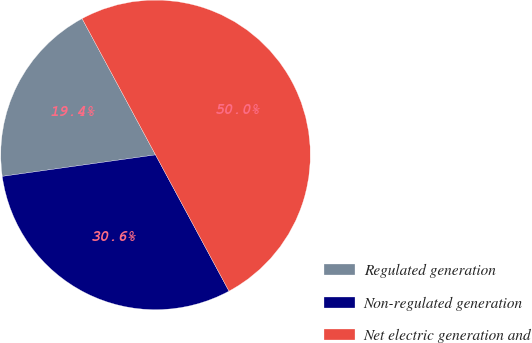Convert chart. <chart><loc_0><loc_0><loc_500><loc_500><pie_chart><fcel>Regulated generation<fcel>Non-regulated generation<fcel>Net electric generation and<nl><fcel>19.35%<fcel>30.65%<fcel>50.0%<nl></chart> 